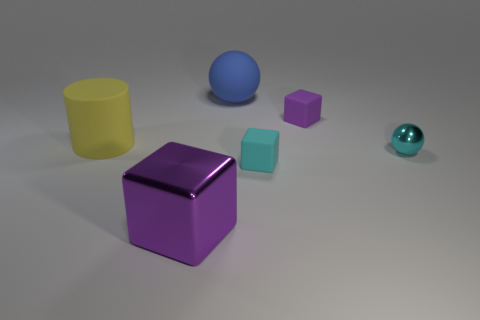Add 3 blue things. How many objects exist? 9 Subtract all purple blocks. How many blocks are left? 1 Subtract 1 cubes. How many cubes are left? 2 Subtract all purple cubes. How many cubes are left? 1 Subtract all spheres. How many objects are left? 4 Subtract all blue cylinders. How many purple blocks are left? 2 Subtract all small red cylinders. Subtract all big matte cylinders. How many objects are left? 5 Add 5 big purple objects. How many big purple objects are left? 6 Add 3 cyan matte things. How many cyan matte things exist? 4 Subtract 0 brown balls. How many objects are left? 6 